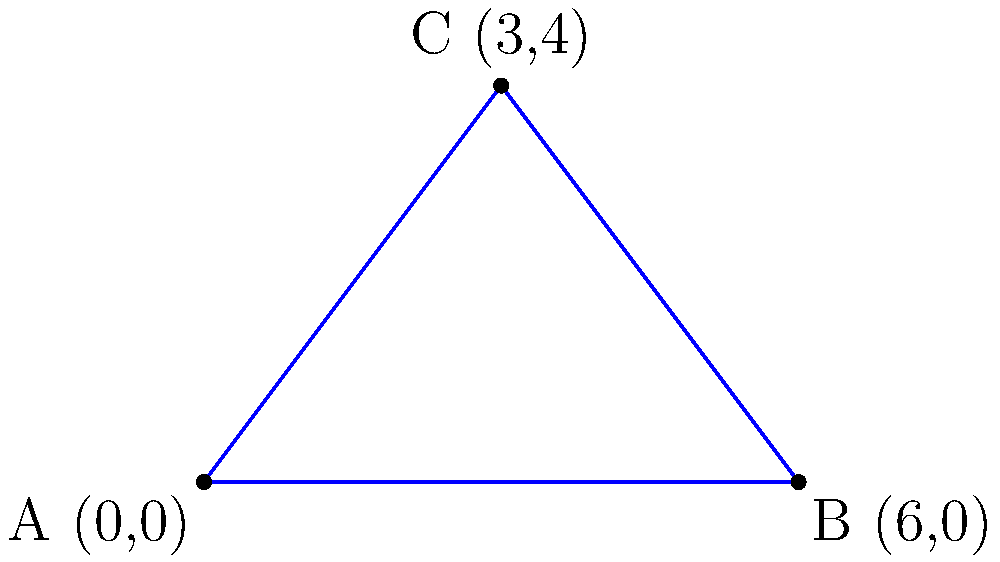In a strategic defensive formation, three units are positioned at points A(0,0), B(6,0), and C(3,4) on a coordinate grid. Calculate the area of the triangular region formed by these units to determine the coverage of the defensive perimeter. To find the area of the triangle formed by points A(0,0), B(6,0), and C(3,4), we can use the formula for the area of a triangle given three coordinate points:

Area = $\frac{1}{2}|x_1(y_2 - y_3) + x_2(y_3 - y_1) + x_3(y_1 - y_2)|$

Where $(x_1, y_1)$, $(x_2, y_2)$, and $(x_3, y_3)$ are the coordinates of the three points.

Step 1: Identify the coordinates
A: $(x_1, y_1) = (0, 0)$
B: $(x_2, y_2) = (6, 0)$
C: $(x_3, y_3) = (3, 4)$

Step 2: Substitute the values into the formula
Area = $\frac{1}{2}|0(0 - 4) + 6(4 - 0) + 3(0 - 0)|$

Step 3: Simplify
Area = $\frac{1}{2}|0 + 24 + 0|$
Area = $\frac{1}{2}|24|$
Area = $\frac{1}{2} \cdot 24$
Area = 12

Therefore, the area of the triangular defensive formation is 12 square units.
Answer: 12 square units 